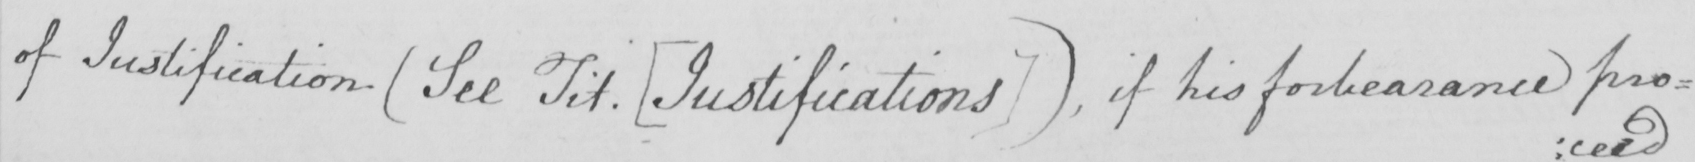Please transcribe the handwritten text in this image. Of Justification  ( See Tit .  [ Justifications ]  )  , if his forebearance pro : 